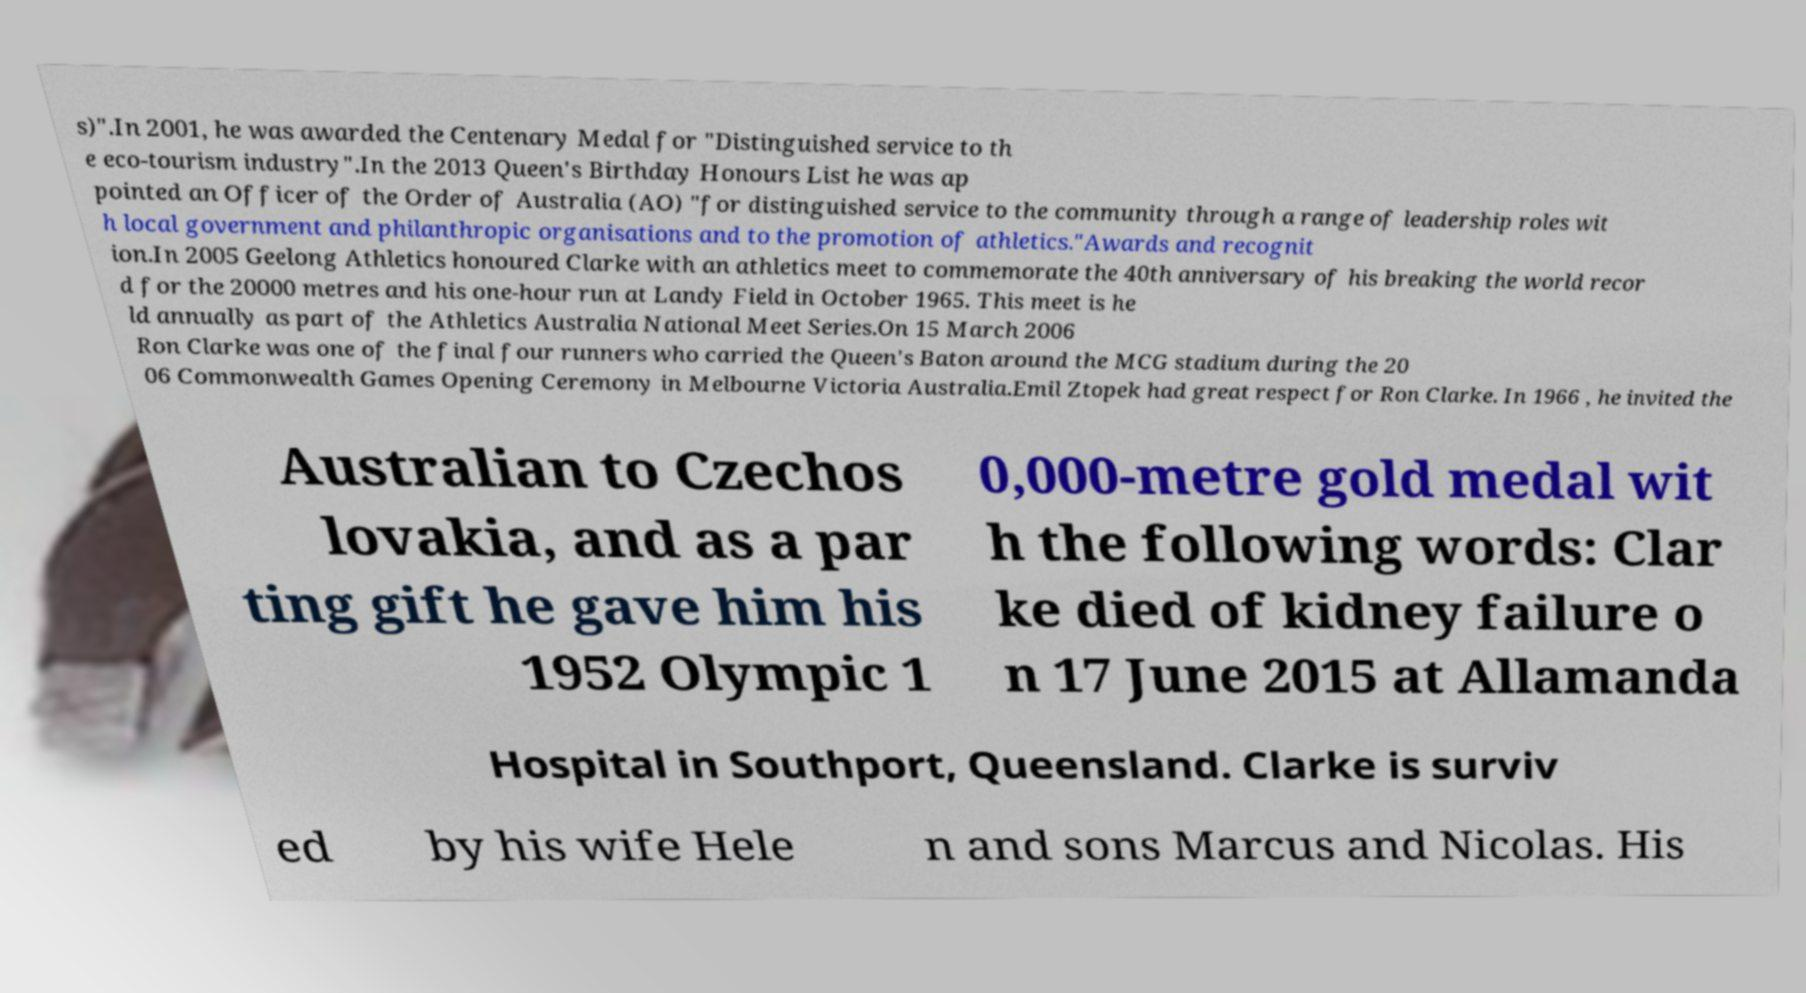There's text embedded in this image that I need extracted. Can you transcribe it verbatim? s)".In 2001, he was awarded the Centenary Medal for "Distinguished service to th e eco-tourism industry".In the 2013 Queen's Birthday Honours List he was ap pointed an Officer of the Order of Australia (AO) "for distinguished service to the community through a range of leadership roles wit h local government and philanthropic organisations and to the promotion of athletics."Awards and recognit ion.In 2005 Geelong Athletics honoured Clarke with an athletics meet to commemorate the 40th anniversary of his breaking the world recor d for the 20000 metres and his one-hour run at Landy Field in October 1965. This meet is he ld annually as part of the Athletics Australia National Meet Series.On 15 March 2006 Ron Clarke was one of the final four runners who carried the Queen's Baton around the MCG stadium during the 20 06 Commonwealth Games Opening Ceremony in Melbourne Victoria Australia.Emil Ztopek had great respect for Ron Clarke. In 1966 , he invited the Australian to Czechos lovakia, and as a par ting gift he gave him his 1952 Olympic 1 0,000-metre gold medal wit h the following words: Clar ke died of kidney failure o n 17 June 2015 at Allamanda Hospital in Southport, Queensland. Clarke is surviv ed by his wife Hele n and sons Marcus and Nicolas. His 